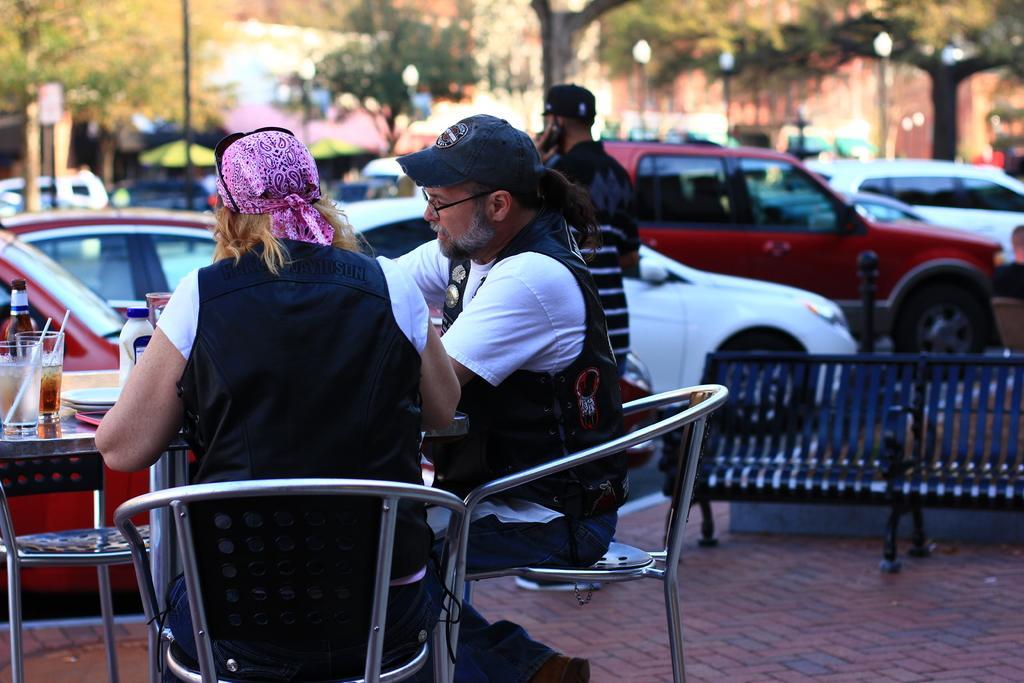Could you give a brief overview of what you see in this image? In this picture there are two people sitting on the chairs, with some wine bottles and wine glass kept on a table also there are some plates. In the backdrop there are vehicles and trees. 